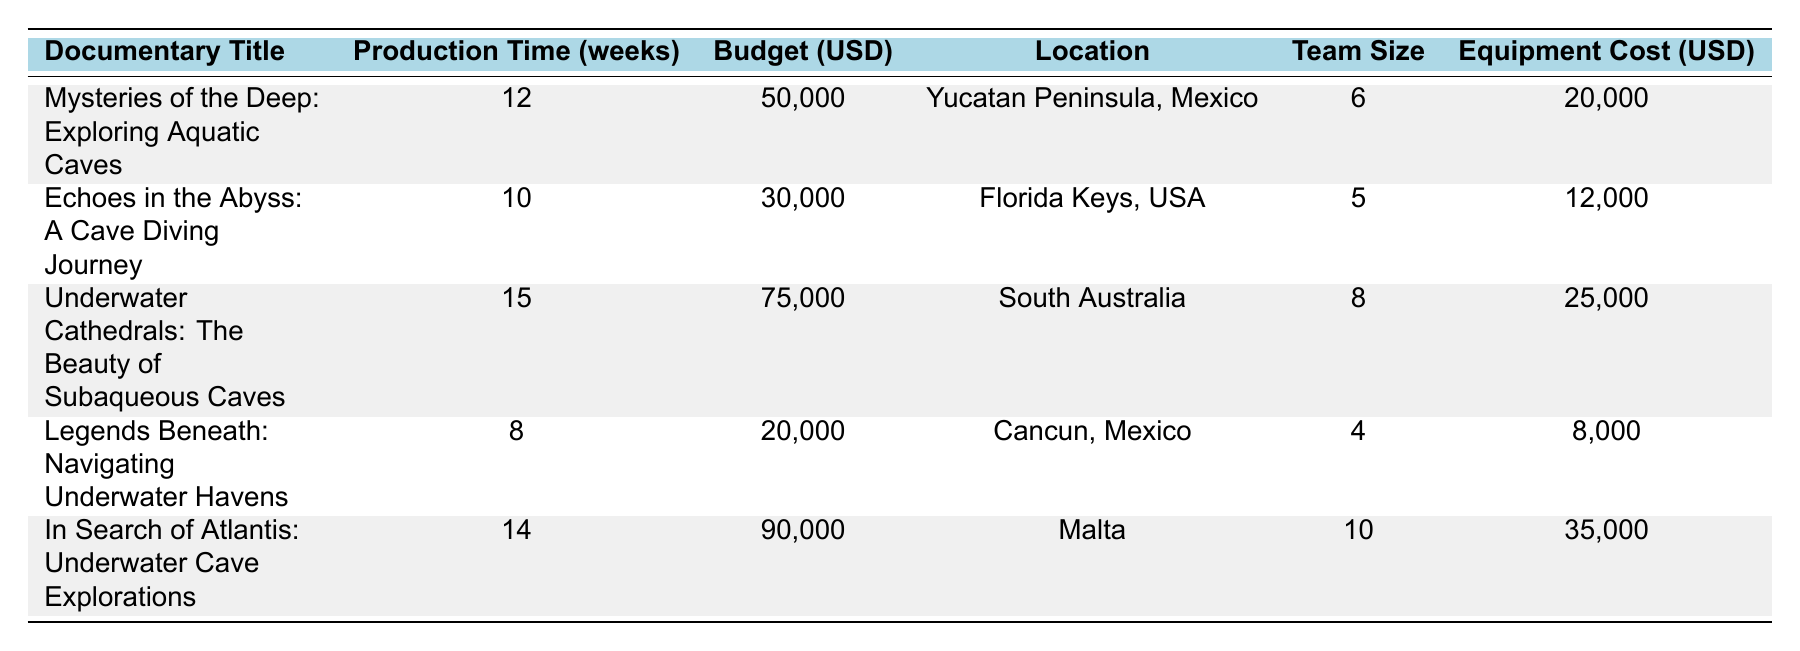What is the budget for "Echoes in the Abyss: A Cave Diving Journey"? The table provides the budget value directly next to the title "Echoes in the Abyss: A Cave Diving Journey", which is listed as 30,000 USD.
Answer: 30,000 USD Which documentary has the longest production time? By comparing the production time values listed next to each title, "Underwater Cathedrals: The Beauty of Subaqueous Caves" has the longest production time of 15 weeks.
Answer: Underwater Cathedrals: The Beauty of Subaqueous Caves What is the total budget allocated for the documentaries located in Mexico? The documentaries in Mexico are "Mysteries of the Deep: Exploring Aquatic Caves" and "Legends Beneath: Navigating Underwater Havens". Their budgets are 50,000 and 20,000 USD respectively. Summing these gives 50,000 + 20,000 = 70,000 USD.
Answer: 70,000 USD How many documentaries have a team size greater than 6? The documents' team sizes can be checked: "Underwater Cathedrals" has 8 and "In Search of Atlantis" has 10, making a total of 2 documentaries with a team size greater than 6.
Answer: 2 What is the average equipment cost for all documentaries? The equipment costs are: 20,000, 12,000, 25,000, 8,000, and 35,000 USD. To find the average, add these together (20,000 + 12,000 + 25,000 + 8,000 + 35,000 = 100,000) and divide by the number of documentaries (5). The average is 100,000 / 5 = 20,000 USD.
Answer: 20,000 USD Is the marketing budget for "In Search of Atlantis: Underwater Cave Explorations" less than the post-production cost? For "In Search of Atlantis", the marketing budget is 5,000 USD and the post-production cost is 30,000 USD. Since 5,000 is less than 30,000, the answer is true.
Answer: Yes Which documentary has the highest equipment cost and what is that cost? By checking the equipment costs provided, "In Search of Atlantis: Underwater Cave Explorations" has the highest at 35,000 USD.
Answer: 35,000 USD What percentage of the total budget is allocated for equipment costs for "Underwater Cathedrals"? The budget for "Underwater Cathedrals" is 75,000 USD and the equipment cost is 25,000 USD. To find the percentage, use the formula (equipment cost / total budget) * 100, which is (25,000 / 75,000) * 100 = 33.33%.
Answer: 33.33% How many weeks does it take to produce the least time-consuming documentary? The least time-consuming documentary is "Legends Beneath: Navigating Underwater Havens" with a production time of 8 weeks as listed.
Answer: 8 weeks If the post-production cost is doubled in "Echoes in the Abyss: A Cave Diving Journey," what will be the new budget? The original budget for "Echoes in the Abyss" is 30,000 USD and the post-production cost is 8,000 USD. Doubling it makes the new post-production cost 16,000 USD. Therefore, the new budget will be 30,000 - 8,000 + 16,000 = 38,000 USD.
Answer: 38,000 USD 